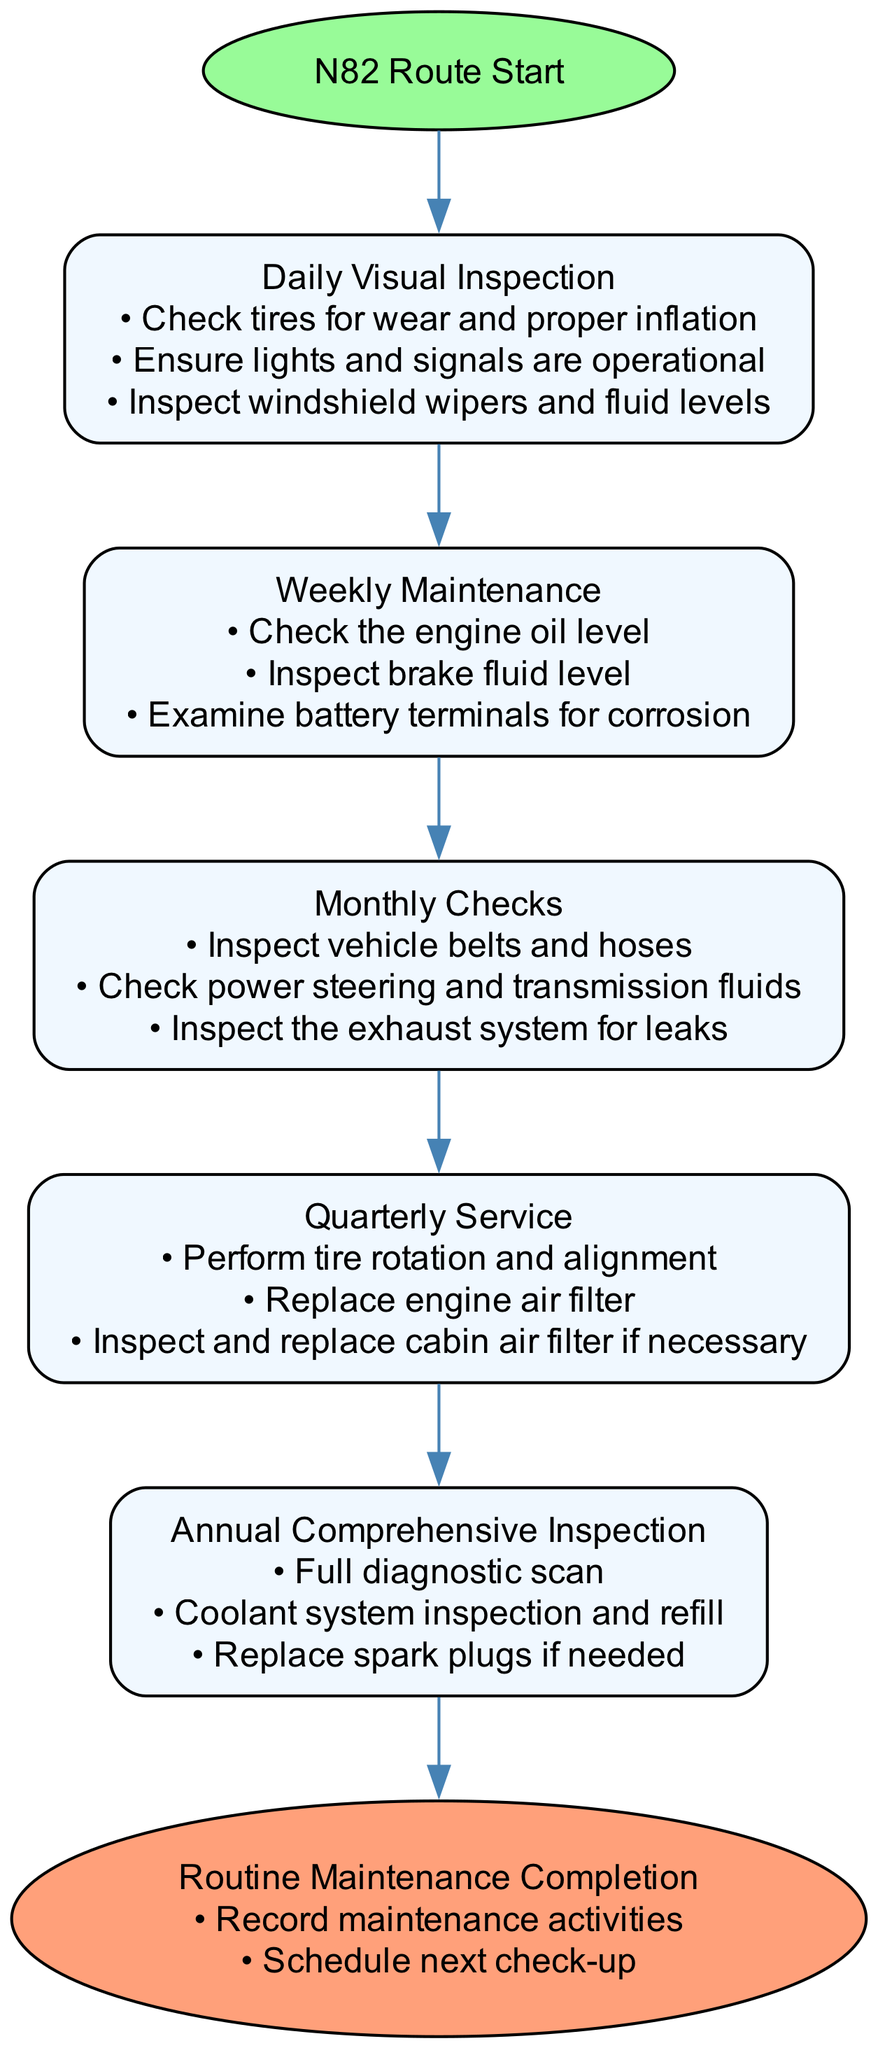What is the starting point of the pathway? The diagram shows the starting point labeled "N82 Route Start". This is the entry point before any tasks commence.
Answer: N82 Route Start How many tasks are outlined in the pathway? By counting the tasks listed in the elements of the diagram, there are five distinct tasks that are part of the pathway before the endpoint.
Answer: 5 What is the last task before the routine maintenance completion? The diagram indicates that the last task is the "Annual Comprehensive Inspection", which is directly connected to the routine maintenance completion.
Answer: Annual Comprehensive Inspection What do you inspect in the daily visual inspection task? The details under the "Daily Visual Inspection" task list the specific items to check, such as tires, lights, and windshield wipers.
Answer: Tires, lights, windshield wipers Which task involves inspecting the exhaust system? The diagram specifies that inspecting the exhaust system is part of the "Monthly Checks". This task is crucial for maintaining vehicle safety.
Answer: Monthly Checks What is recorded at the end of the pathway? The end point of the pathway includes details that indicate recording the maintenance activities as part of the completion process.
Answer: Record maintenance activities How often is a tire rotation performed? The diagram categorizes tire rotation as part of the "Quarterly Service" task, indicating it is performed every three months.
Answer: Quarterly What is the main purpose of the pathway? The diagram outlines that the main purpose is to ensure routine vehicle maintenance and safety checks, representing a structured approach to vehicle care.
Answer: Routine vehicle maintenance and safety checks 